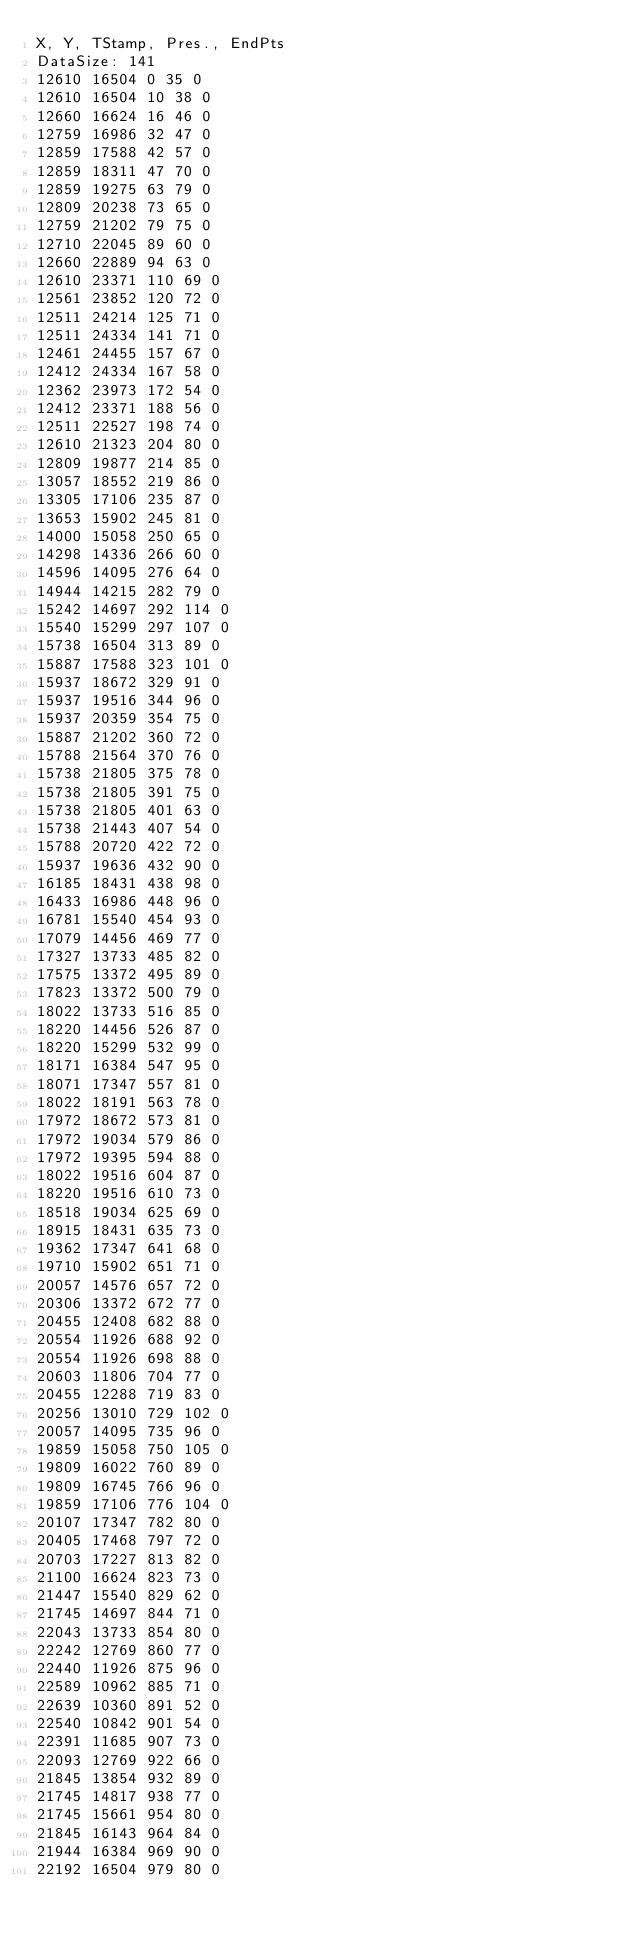<code> <loc_0><loc_0><loc_500><loc_500><_SML_>X, Y, TStamp, Pres., EndPts
DataSize: 141
12610 16504 0 35 0
12610 16504 10 38 0
12660 16624 16 46 0
12759 16986 32 47 0
12859 17588 42 57 0
12859 18311 47 70 0
12859 19275 63 79 0
12809 20238 73 65 0
12759 21202 79 75 0
12710 22045 89 60 0
12660 22889 94 63 0
12610 23371 110 69 0
12561 23852 120 72 0
12511 24214 125 71 0
12511 24334 141 71 0
12461 24455 157 67 0
12412 24334 167 58 0
12362 23973 172 54 0
12412 23371 188 56 0
12511 22527 198 74 0
12610 21323 204 80 0
12809 19877 214 85 0
13057 18552 219 86 0
13305 17106 235 87 0
13653 15902 245 81 0
14000 15058 250 65 0
14298 14336 266 60 0
14596 14095 276 64 0
14944 14215 282 79 0
15242 14697 292 114 0
15540 15299 297 107 0
15738 16504 313 89 0
15887 17588 323 101 0
15937 18672 329 91 0
15937 19516 344 96 0
15937 20359 354 75 0
15887 21202 360 72 0
15788 21564 370 76 0
15738 21805 375 78 0
15738 21805 391 75 0
15738 21805 401 63 0
15738 21443 407 54 0
15788 20720 422 72 0
15937 19636 432 90 0
16185 18431 438 98 0
16433 16986 448 96 0
16781 15540 454 93 0
17079 14456 469 77 0
17327 13733 485 82 0
17575 13372 495 89 0
17823 13372 500 79 0
18022 13733 516 85 0
18220 14456 526 87 0
18220 15299 532 99 0
18171 16384 547 95 0
18071 17347 557 81 0
18022 18191 563 78 0
17972 18672 573 81 0
17972 19034 579 86 0
17972 19395 594 88 0
18022 19516 604 87 0
18220 19516 610 73 0
18518 19034 625 69 0
18915 18431 635 73 0
19362 17347 641 68 0
19710 15902 651 71 0
20057 14576 657 72 0
20306 13372 672 77 0
20455 12408 682 88 0
20554 11926 688 92 0
20554 11926 698 88 0
20603 11806 704 77 0
20455 12288 719 83 0
20256 13010 729 102 0
20057 14095 735 96 0
19859 15058 750 105 0
19809 16022 760 89 0
19809 16745 766 96 0
19859 17106 776 104 0
20107 17347 782 80 0
20405 17468 797 72 0
20703 17227 813 82 0
21100 16624 823 73 0
21447 15540 829 62 0
21745 14697 844 71 0
22043 13733 854 80 0
22242 12769 860 77 0
22440 11926 875 96 0
22589 10962 885 71 0
22639 10360 891 52 0
22540 10842 901 54 0
22391 11685 907 73 0
22093 12769 922 66 0
21845 13854 932 89 0
21745 14817 938 77 0
21745 15661 954 80 0
21845 16143 964 84 0
21944 16384 969 90 0
22192 16504 979 80 0</code> 